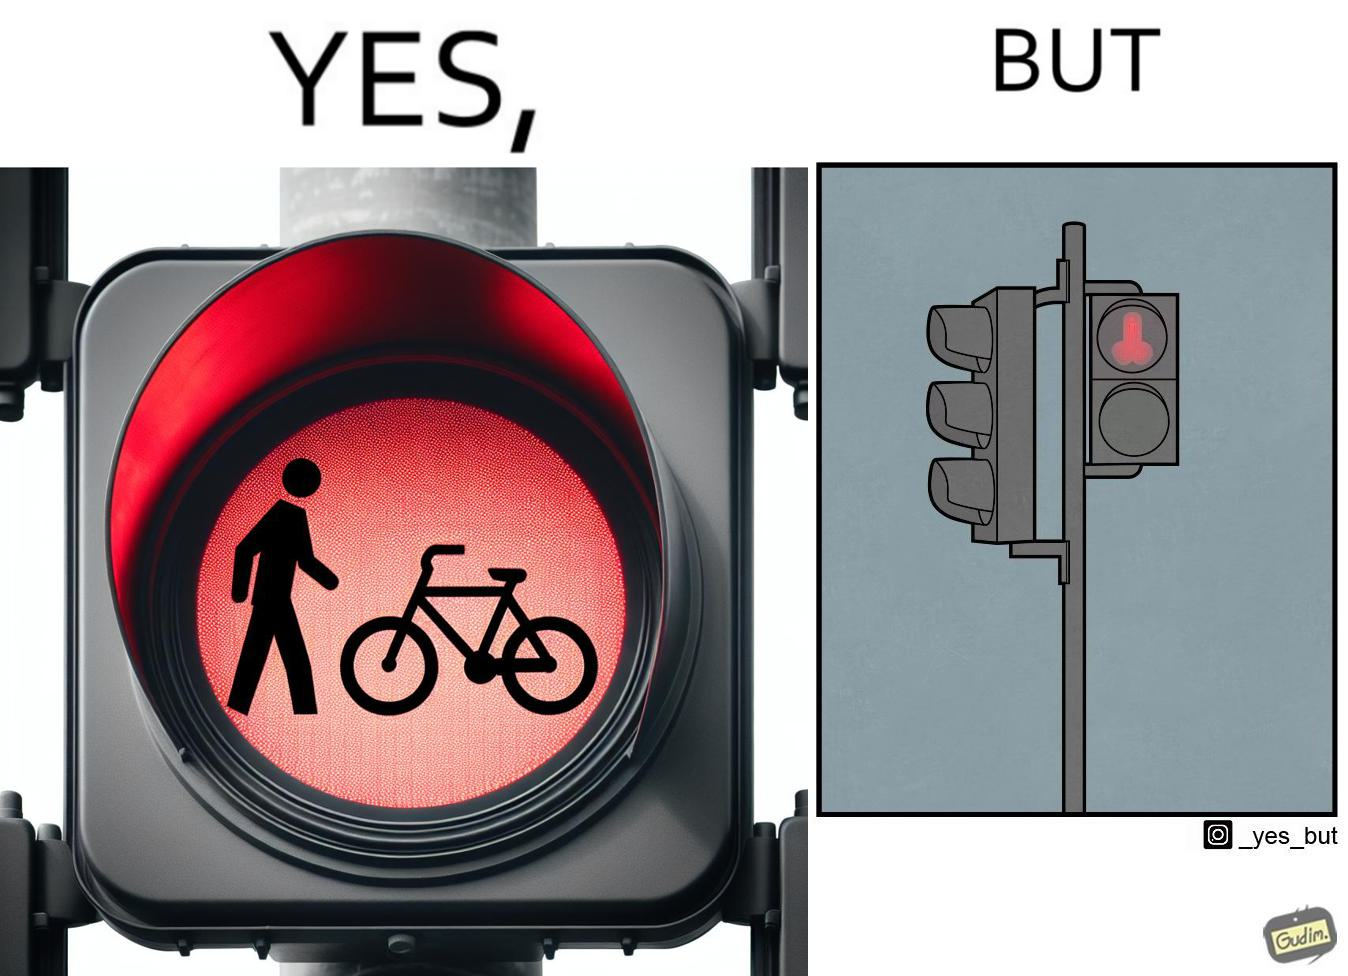Describe the contrast between the left and right parts of this image. In the left part of the image: A close up image of a traffic light meant for pedestrians and bicycles. The light has a stick figure of a human placed vertically above a drawing of a bicycle. Both are lit up in red, and inside the same circle. In the right part of the image: A traffic light pole with 2 lights.  Currently  the top red light is lit up. The light is a pedestrian light, but the symbol on it looks phallic, 2  circles and a cylinder between them. It is presumably not meant to look phallic but the  distance blurs the actual figures on the light. 